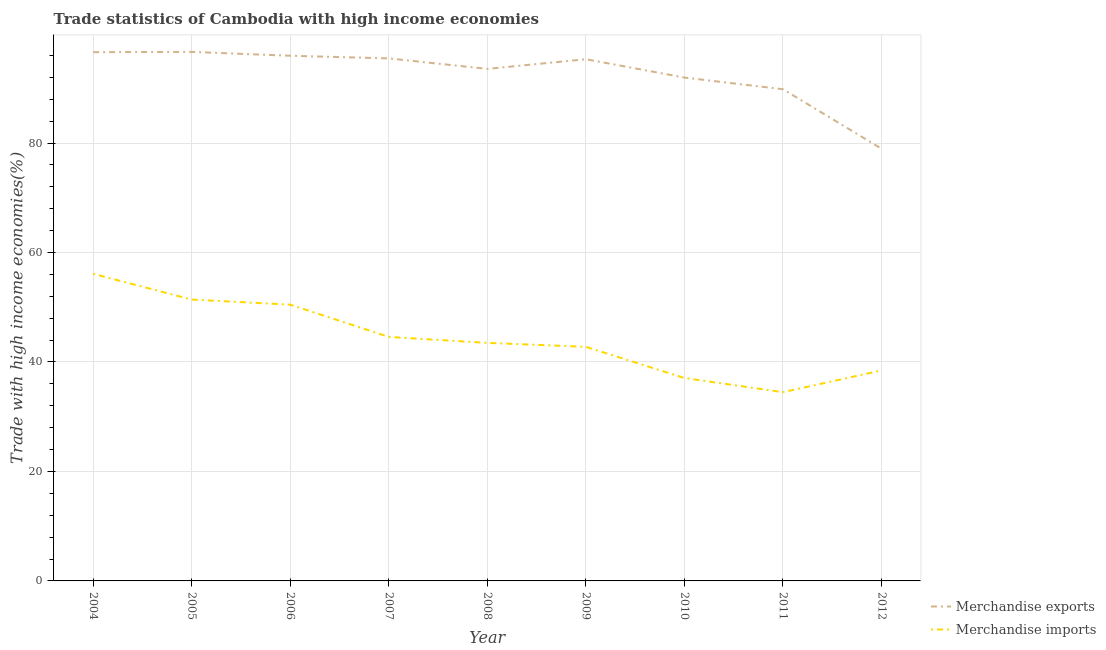Does the line corresponding to merchandise imports intersect with the line corresponding to merchandise exports?
Ensure brevity in your answer.  No. Is the number of lines equal to the number of legend labels?
Your answer should be very brief. Yes. What is the merchandise imports in 2006?
Your response must be concise. 50.47. Across all years, what is the maximum merchandise imports?
Offer a very short reply. 56.1. Across all years, what is the minimum merchandise imports?
Keep it short and to the point. 34.48. What is the total merchandise imports in the graph?
Offer a terse response. 398.79. What is the difference between the merchandise imports in 2005 and that in 2012?
Provide a short and direct response. 12.94. What is the difference between the merchandise imports in 2004 and the merchandise exports in 2010?
Keep it short and to the point. -35.85. What is the average merchandise imports per year?
Provide a succinct answer. 44.31. In the year 2004, what is the difference between the merchandise exports and merchandise imports?
Offer a terse response. 40.49. In how many years, is the merchandise exports greater than 92 %?
Give a very brief answer. 6. What is the ratio of the merchandise exports in 2006 to that in 2012?
Provide a succinct answer. 1.22. Is the merchandise imports in 2005 less than that in 2010?
Provide a succinct answer. No. Is the difference between the merchandise exports in 2010 and 2011 greater than the difference between the merchandise imports in 2010 and 2011?
Provide a succinct answer. No. What is the difference between the highest and the second highest merchandise imports?
Offer a terse response. 4.7. What is the difference between the highest and the lowest merchandise imports?
Your response must be concise. 21.62. In how many years, is the merchandise imports greater than the average merchandise imports taken over all years?
Give a very brief answer. 4. Is the sum of the merchandise imports in 2005 and 2007 greater than the maximum merchandise exports across all years?
Keep it short and to the point. No. How many lines are there?
Your answer should be very brief. 2. Does the graph contain any zero values?
Offer a very short reply. No. How many legend labels are there?
Make the answer very short. 2. How are the legend labels stacked?
Offer a terse response. Vertical. What is the title of the graph?
Offer a very short reply. Trade statistics of Cambodia with high income economies. What is the label or title of the Y-axis?
Your response must be concise. Trade with high income economies(%). What is the Trade with high income economies(%) in Merchandise exports in 2004?
Ensure brevity in your answer.  96.59. What is the Trade with high income economies(%) of Merchandise imports in 2004?
Your answer should be very brief. 56.1. What is the Trade with high income economies(%) of Merchandise exports in 2005?
Your answer should be compact. 96.65. What is the Trade with high income economies(%) of Merchandise imports in 2005?
Offer a terse response. 51.4. What is the Trade with high income economies(%) in Merchandise exports in 2006?
Offer a terse response. 95.94. What is the Trade with high income economies(%) of Merchandise imports in 2006?
Make the answer very short. 50.47. What is the Trade with high income economies(%) in Merchandise exports in 2007?
Your answer should be very brief. 95.46. What is the Trade with high income economies(%) of Merchandise imports in 2007?
Keep it short and to the point. 44.57. What is the Trade with high income economies(%) of Merchandise exports in 2008?
Your answer should be very brief. 93.54. What is the Trade with high income economies(%) of Merchandise imports in 2008?
Your answer should be very brief. 43.49. What is the Trade with high income economies(%) in Merchandise exports in 2009?
Give a very brief answer. 95.3. What is the Trade with high income economies(%) of Merchandise imports in 2009?
Provide a short and direct response. 42.76. What is the Trade with high income economies(%) in Merchandise exports in 2010?
Your answer should be very brief. 91.95. What is the Trade with high income economies(%) of Merchandise imports in 2010?
Provide a short and direct response. 37.07. What is the Trade with high income economies(%) in Merchandise exports in 2011?
Offer a terse response. 89.82. What is the Trade with high income economies(%) in Merchandise imports in 2011?
Provide a succinct answer. 34.48. What is the Trade with high income economies(%) in Merchandise exports in 2012?
Ensure brevity in your answer.  78.95. What is the Trade with high income economies(%) in Merchandise imports in 2012?
Keep it short and to the point. 38.46. Across all years, what is the maximum Trade with high income economies(%) in Merchandise exports?
Give a very brief answer. 96.65. Across all years, what is the maximum Trade with high income economies(%) of Merchandise imports?
Offer a terse response. 56.1. Across all years, what is the minimum Trade with high income economies(%) in Merchandise exports?
Make the answer very short. 78.95. Across all years, what is the minimum Trade with high income economies(%) in Merchandise imports?
Your answer should be compact. 34.48. What is the total Trade with high income economies(%) of Merchandise exports in the graph?
Your answer should be compact. 834.21. What is the total Trade with high income economies(%) of Merchandise imports in the graph?
Provide a succinct answer. 398.79. What is the difference between the Trade with high income economies(%) in Merchandise exports in 2004 and that in 2005?
Keep it short and to the point. -0.05. What is the difference between the Trade with high income economies(%) in Merchandise imports in 2004 and that in 2005?
Your response must be concise. 4.7. What is the difference between the Trade with high income economies(%) of Merchandise exports in 2004 and that in 2006?
Give a very brief answer. 0.65. What is the difference between the Trade with high income economies(%) in Merchandise imports in 2004 and that in 2006?
Provide a succinct answer. 5.63. What is the difference between the Trade with high income economies(%) in Merchandise exports in 2004 and that in 2007?
Provide a short and direct response. 1.14. What is the difference between the Trade with high income economies(%) in Merchandise imports in 2004 and that in 2007?
Give a very brief answer. 11.53. What is the difference between the Trade with high income economies(%) of Merchandise exports in 2004 and that in 2008?
Make the answer very short. 3.06. What is the difference between the Trade with high income economies(%) of Merchandise imports in 2004 and that in 2008?
Your response must be concise. 12.61. What is the difference between the Trade with high income economies(%) in Merchandise exports in 2004 and that in 2009?
Provide a short and direct response. 1.29. What is the difference between the Trade with high income economies(%) in Merchandise imports in 2004 and that in 2009?
Keep it short and to the point. 13.34. What is the difference between the Trade with high income economies(%) in Merchandise exports in 2004 and that in 2010?
Ensure brevity in your answer.  4.64. What is the difference between the Trade with high income economies(%) of Merchandise imports in 2004 and that in 2010?
Your answer should be compact. 19.03. What is the difference between the Trade with high income economies(%) in Merchandise exports in 2004 and that in 2011?
Make the answer very short. 6.77. What is the difference between the Trade with high income economies(%) in Merchandise imports in 2004 and that in 2011?
Your response must be concise. 21.62. What is the difference between the Trade with high income economies(%) of Merchandise exports in 2004 and that in 2012?
Provide a succinct answer. 17.64. What is the difference between the Trade with high income economies(%) in Merchandise imports in 2004 and that in 2012?
Your answer should be very brief. 17.64. What is the difference between the Trade with high income economies(%) of Merchandise exports in 2005 and that in 2006?
Make the answer very short. 0.71. What is the difference between the Trade with high income economies(%) of Merchandise imports in 2005 and that in 2006?
Make the answer very short. 0.93. What is the difference between the Trade with high income economies(%) of Merchandise exports in 2005 and that in 2007?
Ensure brevity in your answer.  1.19. What is the difference between the Trade with high income economies(%) of Merchandise imports in 2005 and that in 2007?
Your answer should be compact. 6.82. What is the difference between the Trade with high income economies(%) in Merchandise exports in 2005 and that in 2008?
Your answer should be very brief. 3.11. What is the difference between the Trade with high income economies(%) in Merchandise imports in 2005 and that in 2008?
Give a very brief answer. 7.91. What is the difference between the Trade with high income economies(%) of Merchandise exports in 2005 and that in 2009?
Ensure brevity in your answer.  1.34. What is the difference between the Trade with high income economies(%) in Merchandise imports in 2005 and that in 2009?
Your answer should be compact. 8.64. What is the difference between the Trade with high income economies(%) in Merchandise exports in 2005 and that in 2010?
Provide a succinct answer. 4.69. What is the difference between the Trade with high income economies(%) of Merchandise imports in 2005 and that in 2010?
Give a very brief answer. 14.33. What is the difference between the Trade with high income economies(%) of Merchandise exports in 2005 and that in 2011?
Keep it short and to the point. 6.82. What is the difference between the Trade with high income economies(%) of Merchandise imports in 2005 and that in 2011?
Give a very brief answer. 16.92. What is the difference between the Trade with high income economies(%) in Merchandise exports in 2005 and that in 2012?
Offer a terse response. 17.69. What is the difference between the Trade with high income economies(%) in Merchandise imports in 2005 and that in 2012?
Keep it short and to the point. 12.94. What is the difference between the Trade with high income economies(%) of Merchandise exports in 2006 and that in 2007?
Provide a short and direct response. 0.48. What is the difference between the Trade with high income economies(%) in Merchandise imports in 2006 and that in 2007?
Your answer should be compact. 5.89. What is the difference between the Trade with high income economies(%) in Merchandise exports in 2006 and that in 2008?
Ensure brevity in your answer.  2.4. What is the difference between the Trade with high income economies(%) in Merchandise imports in 2006 and that in 2008?
Ensure brevity in your answer.  6.98. What is the difference between the Trade with high income economies(%) of Merchandise exports in 2006 and that in 2009?
Your answer should be compact. 0.64. What is the difference between the Trade with high income economies(%) in Merchandise imports in 2006 and that in 2009?
Provide a short and direct response. 7.71. What is the difference between the Trade with high income economies(%) in Merchandise exports in 2006 and that in 2010?
Your answer should be compact. 3.99. What is the difference between the Trade with high income economies(%) of Merchandise imports in 2006 and that in 2010?
Offer a very short reply. 13.4. What is the difference between the Trade with high income economies(%) in Merchandise exports in 2006 and that in 2011?
Your answer should be compact. 6.12. What is the difference between the Trade with high income economies(%) of Merchandise imports in 2006 and that in 2011?
Your answer should be very brief. 15.99. What is the difference between the Trade with high income economies(%) of Merchandise exports in 2006 and that in 2012?
Your response must be concise. 16.99. What is the difference between the Trade with high income economies(%) in Merchandise imports in 2006 and that in 2012?
Your response must be concise. 12.01. What is the difference between the Trade with high income economies(%) of Merchandise exports in 2007 and that in 2008?
Offer a very short reply. 1.92. What is the difference between the Trade with high income economies(%) in Merchandise imports in 2007 and that in 2008?
Your response must be concise. 1.09. What is the difference between the Trade with high income economies(%) of Merchandise exports in 2007 and that in 2009?
Provide a short and direct response. 0.15. What is the difference between the Trade with high income economies(%) of Merchandise imports in 2007 and that in 2009?
Keep it short and to the point. 1.81. What is the difference between the Trade with high income economies(%) in Merchandise exports in 2007 and that in 2010?
Provide a succinct answer. 3.5. What is the difference between the Trade with high income economies(%) of Merchandise imports in 2007 and that in 2010?
Ensure brevity in your answer.  7.51. What is the difference between the Trade with high income economies(%) in Merchandise exports in 2007 and that in 2011?
Provide a succinct answer. 5.63. What is the difference between the Trade with high income economies(%) of Merchandise imports in 2007 and that in 2011?
Keep it short and to the point. 10.1. What is the difference between the Trade with high income economies(%) of Merchandise exports in 2007 and that in 2012?
Provide a succinct answer. 16.51. What is the difference between the Trade with high income economies(%) of Merchandise imports in 2007 and that in 2012?
Your response must be concise. 6.12. What is the difference between the Trade with high income economies(%) of Merchandise exports in 2008 and that in 2009?
Your response must be concise. -1.77. What is the difference between the Trade with high income economies(%) in Merchandise imports in 2008 and that in 2009?
Keep it short and to the point. 0.73. What is the difference between the Trade with high income economies(%) of Merchandise exports in 2008 and that in 2010?
Your answer should be compact. 1.58. What is the difference between the Trade with high income economies(%) in Merchandise imports in 2008 and that in 2010?
Provide a short and direct response. 6.42. What is the difference between the Trade with high income economies(%) of Merchandise exports in 2008 and that in 2011?
Your answer should be compact. 3.71. What is the difference between the Trade with high income economies(%) in Merchandise imports in 2008 and that in 2011?
Offer a very short reply. 9.01. What is the difference between the Trade with high income economies(%) in Merchandise exports in 2008 and that in 2012?
Ensure brevity in your answer.  14.59. What is the difference between the Trade with high income economies(%) in Merchandise imports in 2008 and that in 2012?
Your answer should be very brief. 5.03. What is the difference between the Trade with high income economies(%) in Merchandise exports in 2009 and that in 2010?
Offer a terse response. 3.35. What is the difference between the Trade with high income economies(%) of Merchandise imports in 2009 and that in 2010?
Your response must be concise. 5.69. What is the difference between the Trade with high income economies(%) in Merchandise exports in 2009 and that in 2011?
Offer a very short reply. 5.48. What is the difference between the Trade with high income economies(%) of Merchandise imports in 2009 and that in 2011?
Offer a terse response. 8.28. What is the difference between the Trade with high income economies(%) of Merchandise exports in 2009 and that in 2012?
Provide a succinct answer. 16.35. What is the difference between the Trade with high income economies(%) in Merchandise imports in 2009 and that in 2012?
Your answer should be very brief. 4.3. What is the difference between the Trade with high income economies(%) in Merchandise exports in 2010 and that in 2011?
Provide a short and direct response. 2.13. What is the difference between the Trade with high income economies(%) in Merchandise imports in 2010 and that in 2011?
Make the answer very short. 2.59. What is the difference between the Trade with high income economies(%) in Merchandise exports in 2010 and that in 2012?
Your response must be concise. 13. What is the difference between the Trade with high income economies(%) in Merchandise imports in 2010 and that in 2012?
Give a very brief answer. -1.39. What is the difference between the Trade with high income economies(%) in Merchandise exports in 2011 and that in 2012?
Your response must be concise. 10.87. What is the difference between the Trade with high income economies(%) of Merchandise imports in 2011 and that in 2012?
Give a very brief answer. -3.98. What is the difference between the Trade with high income economies(%) of Merchandise exports in 2004 and the Trade with high income economies(%) of Merchandise imports in 2005?
Provide a short and direct response. 45.2. What is the difference between the Trade with high income economies(%) of Merchandise exports in 2004 and the Trade with high income economies(%) of Merchandise imports in 2006?
Your answer should be very brief. 46.12. What is the difference between the Trade with high income economies(%) in Merchandise exports in 2004 and the Trade with high income economies(%) in Merchandise imports in 2007?
Provide a succinct answer. 52.02. What is the difference between the Trade with high income economies(%) in Merchandise exports in 2004 and the Trade with high income economies(%) in Merchandise imports in 2008?
Keep it short and to the point. 53.11. What is the difference between the Trade with high income economies(%) in Merchandise exports in 2004 and the Trade with high income economies(%) in Merchandise imports in 2009?
Provide a succinct answer. 53.83. What is the difference between the Trade with high income economies(%) in Merchandise exports in 2004 and the Trade with high income economies(%) in Merchandise imports in 2010?
Your answer should be very brief. 59.53. What is the difference between the Trade with high income economies(%) in Merchandise exports in 2004 and the Trade with high income economies(%) in Merchandise imports in 2011?
Your answer should be very brief. 62.12. What is the difference between the Trade with high income economies(%) in Merchandise exports in 2004 and the Trade with high income economies(%) in Merchandise imports in 2012?
Offer a very short reply. 58.14. What is the difference between the Trade with high income economies(%) in Merchandise exports in 2005 and the Trade with high income economies(%) in Merchandise imports in 2006?
Give a very brief answer. 46.18. What is the difference between the Trade with high income economies(%) of Merchandise exports in 2005 and the Trade with high income economies(%) of Merchandise imports in 2007?
Give a very brief answer. 52.07. What is the difference between the Trade with high income economies(%) in Merchandise exports in 2005 and the Trade with high income economies(%) in Merchandise imports in 2008?
Give a very brief answer. 53.16. What is the difference between the Trade with high income economies(%) of Merchandise exports in 2005 and the Trade with high income economies(%) of Merchandise imports in 2009?
Give a very brief answer. 53.88. What is the difference between the Trade with high income economies(%) of Merchandise exports in 2005 and the Trade with high income economies(%) of Merchandise imports in 2010?
Provide a succinct answer. 59.58. What is the difference between the Trade with high income economies(%) in Merchandise exports in 2005 and the Trade with high income economies(%) in Merchandise imports in 2011?
Your answer should be compact. 62.17. What is the difference between the Trade with high income economies(%) of Merchandise exports in 2005 and the Trade with high income economies(%) of Merchandise imports in 2012?
Provide a succinct answer. 58.19. What is the difference between the Trade with high income economies(%) of Merchandise exports in 2006 and the Trade with high income economies(%) of Merchandise imports in 2007?
Ensure brevity in your answer.  51.37. What is the difference between the Trade with high income economies(%) in Merchandise exports in 2006 and the Trade with high income economies(%) in Merchandise imports in 2008?
Offer a very short reply. 52.45. What is the difference between the Trade with high income economies(%) in Merchandise exports in 2006 and the Trade with high income economies(%) in Merchandise imports in 2009?
Offer a terse response. 53.18. What is the difference between the Trade with high income economies(%) in Merchandise exports in 2006 and the Trade with high income economies(%) in Merchandise imports in 2010?
Offer a very short reply. 58.87. What is the difference between the Trade with high income economies(%) in Merchandise exports in 2006 and the Trade with high income economies(%) in Merchandise imports in 2011?
Offer a very short reply. 61.46. What is the difference between the Trade with high income economies(%) of Merchandise exports in 2006 and the Trade with high income economies(%) of Merchandise imports in 2012?
Offer a very short reply. 57.48. What is the difference between the Trade with high income economies(%) of Merchandise exports in 2007 and the Trade with high income economies(%) of Merchandise imports in 2008?
Offer a terse response. 51.97. What is the difference between the Trade with high income economies(%) of Merchandise exports in 2007 and the Trade with high income economies(%) of Merchandise imports in 2009?
Offer a very short reply. 52.7. What is the difference between the Trade with high income economies(%) of Merchandise exports in 2007 and the Trade with high income economies(%) of Merchandise imports in 2010?
Ensure brevity in your answer.  58.39. What is the difference between the Trade with high income economies(%) in Merchandise exports in 2007 and the Trade with high income economies(%) in Merchandise imports in 2011?
Ensure brevity in your answer.  60.98. What is the difference between the Trade with high income economies(%) of Merchandise exports in 2007 and the Trade with high income economies(%) of Merchandise imports in 2012?
Keep it short and to the point. 57. What is the difference between the Trade with high income economies(%) in Merchandise exports in 2008 and the Trade with high income economies(%) in Merchandise imports in 2009?
Your answer should be compact. 50.78. What is the difference between the Trade with high income economies(%) of Merchandise exports in 2008 and the Trade with high income economies(%) of Merchandise imports in 2010?
Your response must be concise. 56.47. What is the difference between the Trade with high income economies(%) of Merchandise exports in 2008 and the Trade with high income economies(%) of Merchandise imports in 2011?
Offer a very short reply. 59.06. What is the difference between the Trade with high income economies(%) of Merchandise exports in 2008 and the Trade with high income economies(%) of Merchandise imports in 2012?
Your answer should be compact. 55.08. What is the difference between the Trade with high income economies(%) of Merchandise exports in 2009 and the Trade with high income economies(%) of Merchandise imports in 2010?
Your response must be concise. 58.24. What is the difference between the Trade with high income economies(%) of Merchandise exports in 2009 and the Trade with high income economies(%) of Merchandise imports in 2011?
Give a very brief answer. 60.83. What is the difference between the Trade with high income economies(%) in Merchandise exports in 2009 and the Trade with high income economies(%) in Merchandise imports in 2012?
Your response must be concise. 56.85. What is the difference between the Trade with high income economies(%) of Merchandise exports in 2010 and the Trade with high income economies(%) of Merchandise imports in 2011?
Your answer should be compact. 57.48. What is the difference between the Trade with high income economies(%) of Merchandise exports in 2010 and the Trade with high income economies(%) of Merchandise imports in 2012?
Offer a terse response. 53.5. What is the difference between the Trade with high income economies(%) in Merchandise exports in 2011 and the Trade with high income economies(%) in Merchandise imports in 2012?
Provide a succinct answer. 51.37. What is the average Trade with high income economies(%) of Merchandise exports per year?
Make the answer very short. 92.69. What is the average Trade with high income economies(%) of Merchandise imports per year?
Your answer should be compact. 44.31. In the year 2004, what is the difference between the Trade with high income economies(%) of Merchandise exports and Trade with high income economies(%) of Merchandise imports?
Offer a terse response. 40.49. In the year 2005, what is the difference between the Trade with high income economies(%) of Merchandise exports and Trade with high income economies(%) of Merchandise imports?
Keep it short and to the point. 45.25. In the year 2006, what is the difference between the Trade with high income economies(%) of Merchandise exports and Trade with high income economies(%) of Merchandise imports?
Provide a short and direct response. 45.47. In the year 2007, what is the difference between the Trade with high income economies(%) of Merchandise exports and Trade with high income economies(%) of Merchandise imports?
Your response must be concise. 50.88. In the year 2008, what is the difference between the Trade with high income economies(%) of Merchandise exports and Trade with high income economies(%) of Merchandise imports?
Offer a terse response. 50.05. In the year 2009, what is the difference between the Trade with high income economies(%) in Merchandise exports and Trade with high income economies(%) in Merchandise imports?
Provide a succinct answer. 52.54. In the year 2010, what is the difference between the Trade with high income economies(%) of Merchandise exports and Trade with high income economies(%) of Merchandise imports?
Ensure brevity in your answer.  54.89. In the year 2011, what is the difference between the Trade with high income economies(%) of Merchandise exports and Trade with high income economies(%) of Merchandise imports?
Your answer should be compact. 55.35. In the year 2012, what is the difference between the Trade with high income economies(%) of Merchandise exports and Trade with high income economies(%) of Merchandise imports?
Your answer should be compact. 40.49. What is the ratio of the Trade with high income economies(%) in Merchandise exports in 2004 to that in 2005?
Offer a terse response. 1. What is the ratio of the Trade with high income economies(%) in Merchandise imports in 2004 to that in 2005?
Offer a very short reply. 1.09. What is the ratio of the Trade with high income economies(%) of Merchandise exports in 2004 to that in 2006?
Provide a succinct answer. 1.01. What is the ratio of the Trade with high income economies(%) of Merchandise imports in 2004 to that in 2006?
Provide a succinct answer. 1.11. What is the ratio of the Trade with high income economies(%) in Merchandise exports in 2004 to that in 2007?
Offer a terse response. 1.01. What is the ratio of the Trade with high income economies(%) in Merchandise imports in 2004 to that in 2007?
Your response must be concise. 1.26. What is the ratio of the Trade with high income economies(%) of Merchandise exports in 2004 to that in 2008?
Your response must be concise. 1.03. What is the ratio of the Trade with high income economies(%) in Merchandise imports in 2004 to that in 2008?
Your answer should be compact. 1.29. What is the ratio of the Trade with high income economies(%) of Merchandise exports in 2004 to that in 2009?
Offer a terse response. 1.01. What is the ratio of the Trade with high income economies(%) of Merchandise imports in 2004 to that in 2009?
Your answer should be very brief. 1.31. What is the ratio of the Trade with high income economies(%) of Merchandise exports in 2004 to that in 2010?
Ensure brevity in your answer.  1.05. What is the ratio of the Trade with high income economies(%) in Merchandise imports in 2004 to that in 2010?
Provide a succinct answer. 1.51. What is the ratio of the Trade with high income economies(%) in Merchandise exports in 2004 to that in 2011?
Your response must be concise. 1.08. What is the ratio of the Trade with high income economies(%) in Merchandise imports in 2004 to that in 2011?
Give a very brief answer. 1.63. What is the ratio of the Trade with high income economies(%) of Merchandise exports in 2004 to that in 2012?
Make the answer very short. 1.22. What is the ratio of the Trade with high income economies(%) of Merchandise imports in 2004 to that in 2012?
Your response must be concise. 1.46. What is the ratio of the Trade with high income economies(%) of Merchandise exports in 2005 to that in 2006?
Your answer should be compact. 1.01. What is the ratio of the Trade with high income economies(%) in Merchandise imports in 2005 to that in 2006?
Keep it short and to the point. 1.02. What is the ratio of the Trade with high income economies(%) of Merchandise exports in 2005 to that in 2007?
Provide a short and direct response. 1.01. What is the ratio of the Trade with high income economies(%) of Merchandise imports in 2005 to that in 2007?
Your answer should be compact. 1.15. What is the ratio of the Trade with high income economies(%) of Merchandise exports in 2005 to that in 2008?
Your answer should be compact. 1.03. What is the ratio of the Trade with high income economies(%) of Merchandise imports in 2005 to that in 2008?
Ensure brevity in your answer.  1.18. What is the ratio of the Trade with high income economies(%) of Merchandise exports in 2005 to that in 2009?
Provide a succinct answer. 1.01. What is the ratio of the Trade with high income economies(%) in Merchandise imports in 2005 to that in 2009?
Give a very brief answer. 1.2. What is the ratio of the Trade with high income economies(%) of Merchandise exports in 2005 to that in 2010?
Offer a terse response. 1.05. What is the ratio of the Trade with high income economies(%) of Merchandise imports in 2005 to that in 2010?
Provide a succinct answer. 1.39. What is the ratio of the Trade with high income economies(%) of Merchandise exports in 2005 to that in 2011?
Offer a very short reply. 1.08. What is the ratio of the Trade with high income economies(%) in Merchandise imports in 2005 to that in 2011?
Your answer should be compact. 1.49. What is the ratio of the Trade with high income economies(%) in Merchandise exports in 2005 to that in 2012?
Keep it short and to the point. 1.22. What is the ratio of the Trade with high income economies(%) in Merchandise imports in 2005 to that in 2012?
Offer a very short reply. 1.34. What is the ratio of the Trade with high income economies(%) in Merchandise exports in 2006 to that in 2007?
Provide a short and direct response. 1.01. What is the ratio of the Trade with high income economies(%) of Merchandise imports in 2006 to that in 2007?
Your response must be concise. 1.13. What is the ratio of the Trade with high income economies(%) in Merchandise exports in 2006 to that in 2008?
Your response must be concise. 1.03. What is the ratio of the Trade with high income economies(%) of Merchandise imports in 2006 to that in 2008?
Your answer should be compact. 1.16. What is the ratio of the Trade with high income economies(%) in Merchandise exports in 2006 to that in 2009?
Ensure brevity in your answer.  1.01. What is the ratio of the Trade with high income economies(%) in Merchandise imports in 2006 to that in 2009?
Your answer should be very brief. 1.18. What is the ratio of the Trade with high income economies(%) of Merchandise exports in 2006 to that in 2010?
Keep it short and to the point. 1.04. What is the ratio of the Trade with high income economies(%) of Merchandise imports in 2006 to that in 2010?
Provide a succinct answer. 1.36. What is the ratio of the Trade with high income economies(%) in Merchandise exports in 2006 to that in 2011?
Offer a terse response. 1.07. What is the ratio of the Trade with high income economies(%) of Merchandise imports in 2006 to that in 2011?
Give a very brief answer. 1.46. What is the ratio of the Trade with high income economies(%) in Merchandise exports in 2006 to that in 2012?
Provide a short and direct response. 1.22. What is the ratio of the Trade with high income economies(%) of Merchandise imports in 2006 to that in 2012?
Provide a short and direct response. 1.31. What is the ratio of the Trade with high income economies(%) in Merchandise exports in 2007 to that in 2008?
Your answer should be compact. 1.02. What is the ratio of the Trade with high income economies(%) in Merchandise exports in 2007 to that in 2009?
Your response must be concise. 1. What is the ratio of the Trade with high income economies(%) in Merchandise imports in 2007 to that in 2009?
Offer a terse response. 1.04. What is the ratio of the Trade with high income economies(%) in Merchandise exports in 2007 to that in 2010?
Make the answer very short. 1.04. What is the ratio of the Trade with high income economies(%) of Merchandise imports in 2007 to that in 2010?
Your answer should be compact. 1.2. What is the ratio of the Trade with high income economies(%) in Merchandise exports in 2007 to that in 2011?
Your answer should be very brief. 1.06. What is the ratio of the Trade with high income economies(%) of Merchandise imports in 2007 to that in 2011?
Your response must be concise. 1.29. What is the ratio of the Trade with high income economies(%) in Merchandise exports in 2007 to that in 2012?
Give a very brief answer. 1.21. What is the ratio of the Trade with high income economies(%) of Merchandise imports in 2007 to that in 2012?
Provide a short and direct response. 1.16. What is the ratio of the Trade with high income economies(%) in Merchandise exports in 2008 to that in 2009?
Your answer should be very brief. 0.98. What is the ratio of the Trade with high income economies(%) of Merchandise imports in 2008 to that in 2009?
Ensure brevity in your answer.  1.02. What is the ratio of the Trade with high income economies(%) of Merchandise exports in 2008 to that in 2010?
Offer a terse response. 1.02. What is the ratio of the Trade with high income economies(%) in Merchandise imports in 2008 to that in 2010?
Provide a succinct answer. 1.17. What is the ratio of the Trade with high income economies(%) of Merchandise exports in 2008 to that in 2011?
Your response must be concise. 1.04. What is the ratio of the Trade with high income economies(%) in Merchandise imports in 2008 to that in 2011?
Make the answer very short. 1.26. What is the ratio of the Trade with high income economies(%) in Merchandise exports in 2008 to that in 2012?
Offer a very short reply. 1.18. What is the ratio of the Trade with high income economies(%) in Merchandise imports in 2008 to that in 2012?
Provide a succinct answer. 1.13. What is the ratio of the Trade with high income economies(%) of Merchandise exports in 2009 to that in 2010?
Offer a terse response. 1.04. What is the ratio of the Trade with high income economies(%) of Merchandise imports in 2009 to that in 2010?
Provide a short and direct response. 1.15. What is the ratio of the Trade with high income economies(%) in Merchandise exports in 2009 to that in 2011?
Your answer should be very brief. 1.06. What is the ratio of the Trade with high income economies(%) in Merchandise imports in 2009 to that in 2011?
Offer a terse response. 1.24. What is the ratio of the Trade with high income economies(%) of Merchandise exports in 2009 to that in 2012?
Your answer should be compact. 1.21. What is the ratio of the Trade with high income economies(%) of Merchandise imports in 2009 to that in 2012?
Your answer should be compact. 1.11. What is the ratio of the Trade with high income economies(%) of Merchandise exports in 2010 to that in 2011?
Provide a succinct answer. 1.02. What is the ratio of the Trade with high income economies(%) of Merchandise imports in 2010 to that in 2011?
Your answer should be compact. 1.08. What is the ratio of the Trade with high income economies(%) in Merchandise exports in 2010 to that in 2012?
Provide a short and direct response. 1.16. What is the ratio of the Trade with high income economies(%) in Merchandise imports in 2010 to that in 2012?
Offer a terse response. 0.96. What is the ratio of the Trade with high income economies(%) in Merchandise exports in 2011 to that in 2012?
Offer a very short reply. 1.14. What is the ratio of the Trade with high income economies(%) in Merchandise imports in 2011 to that in 2012?
Ensure brevity in your answer.  0.9. What is the difference between the highest and the second highest Trade with high income economies(%) of Merchandise exports?
Give a very brief answer. 0.05. What is the difference between the highest and the second highest Trade with high income economies(%) of Merchandise imports?
Give a very brief answer. 4.7. What is the difference between the highest and the lowest Trade with high income economies(%) in Merchandise exports?
Your answer should be compact. 17.69. What is the difference between the highest and the lowest Trade with high income economies(%) in Merchandise imports?
Provide a succinct answer. 21.62. 